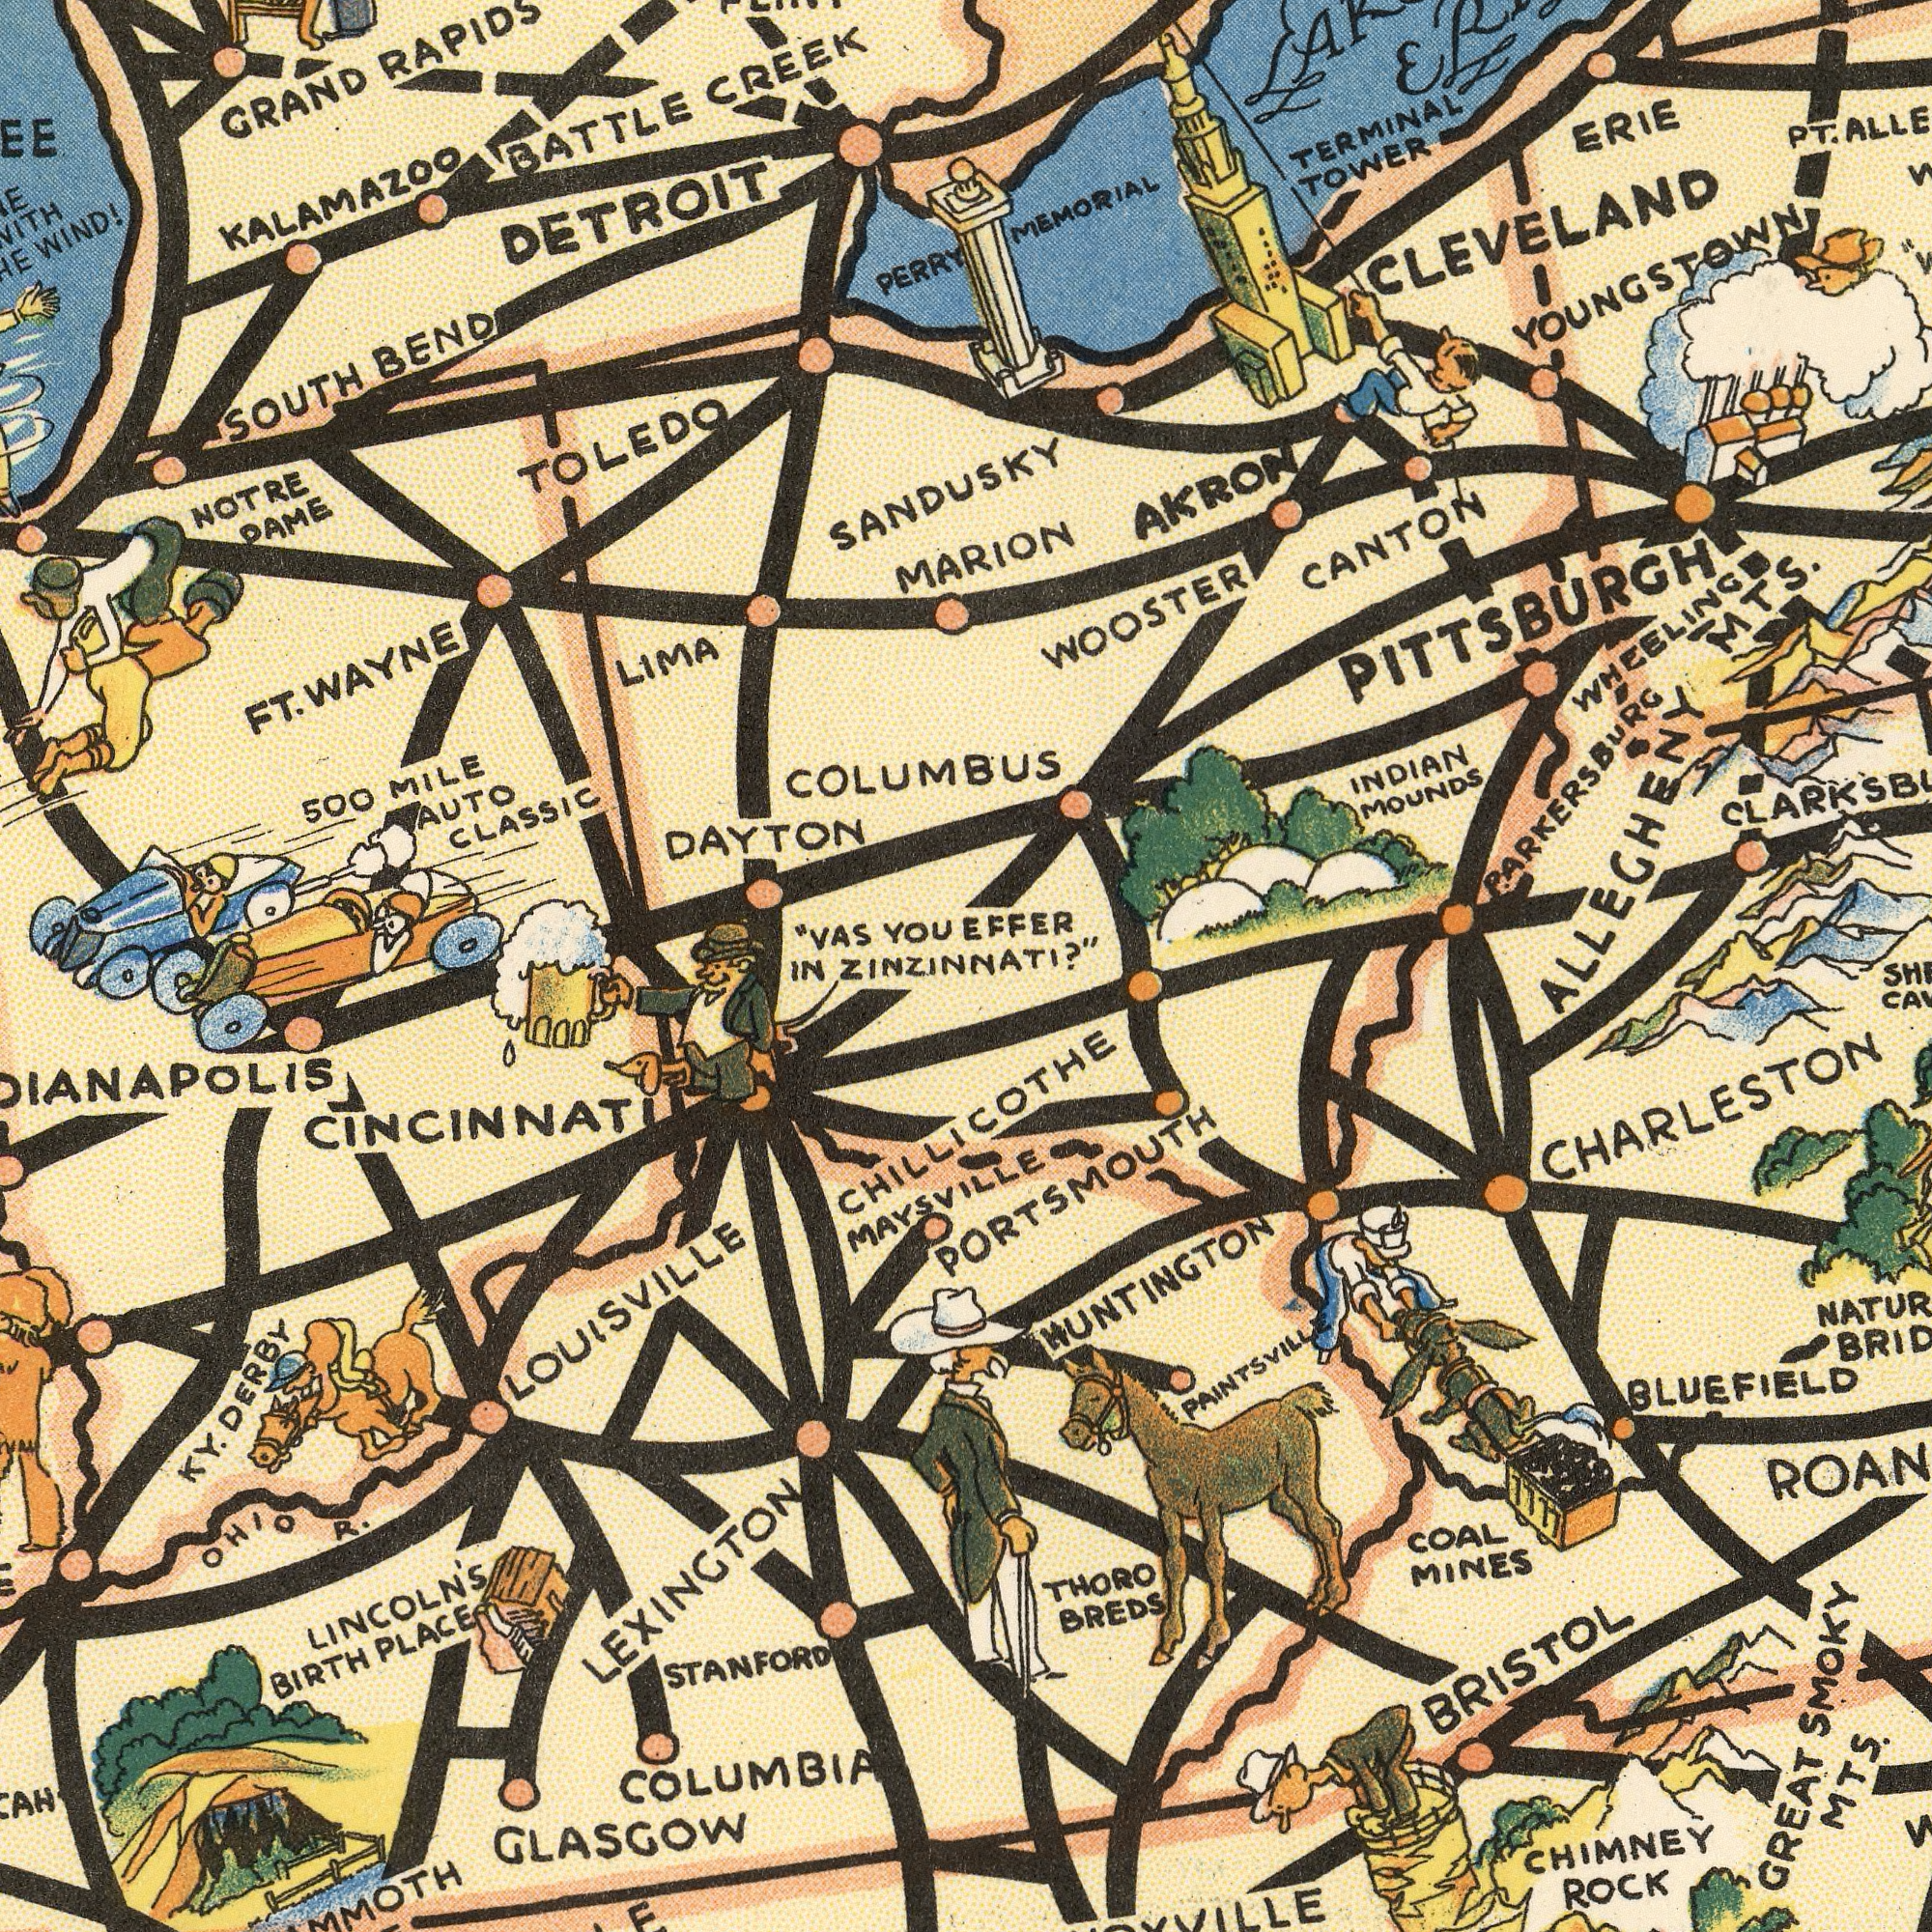What text appears in the bottom-left area of the image? IN STANFORD LINCOLN'S BIRTH PLACE OHIO R. LOUISVILLE KY. DERBY COLUMBIA GLASGOW CINCINNATI LEXINGTON MAYSVILLE What text is shown in the bottom-right quadrant? ZINZINNATI?" BLUEFIELD THORO BREDS CHIMNEY ROCK CHILLICOTHE COAL MINES PAINTSVILLE CHARLESTON BRISTOL GREAT SMOKY MTS. HUNTINGTON PORTSMOUTH What text appears in the top-right area of the image? EFFER MEMORIAL MARION CANTON WOOSTER INDIAN MOUNDS TERMINAL TOWER AKRON ERIE ALLEGHENY MTS. PITTSBURGH PT. YOUNGSTOWN WHEELING PARKERSBURG CLEVELAND What text can you see in the top-left section? GRAND RAPIDS NOTRE DAME TOLEDO COLUMBUS SOUTH BEND BATTLE CREEK LIMA DAYTON 500 MILE AUTO CLASSIC KALAMAZOO "VAS YOU PERRY DETROIT WIND! FT. WAYNE SANDUSKY 